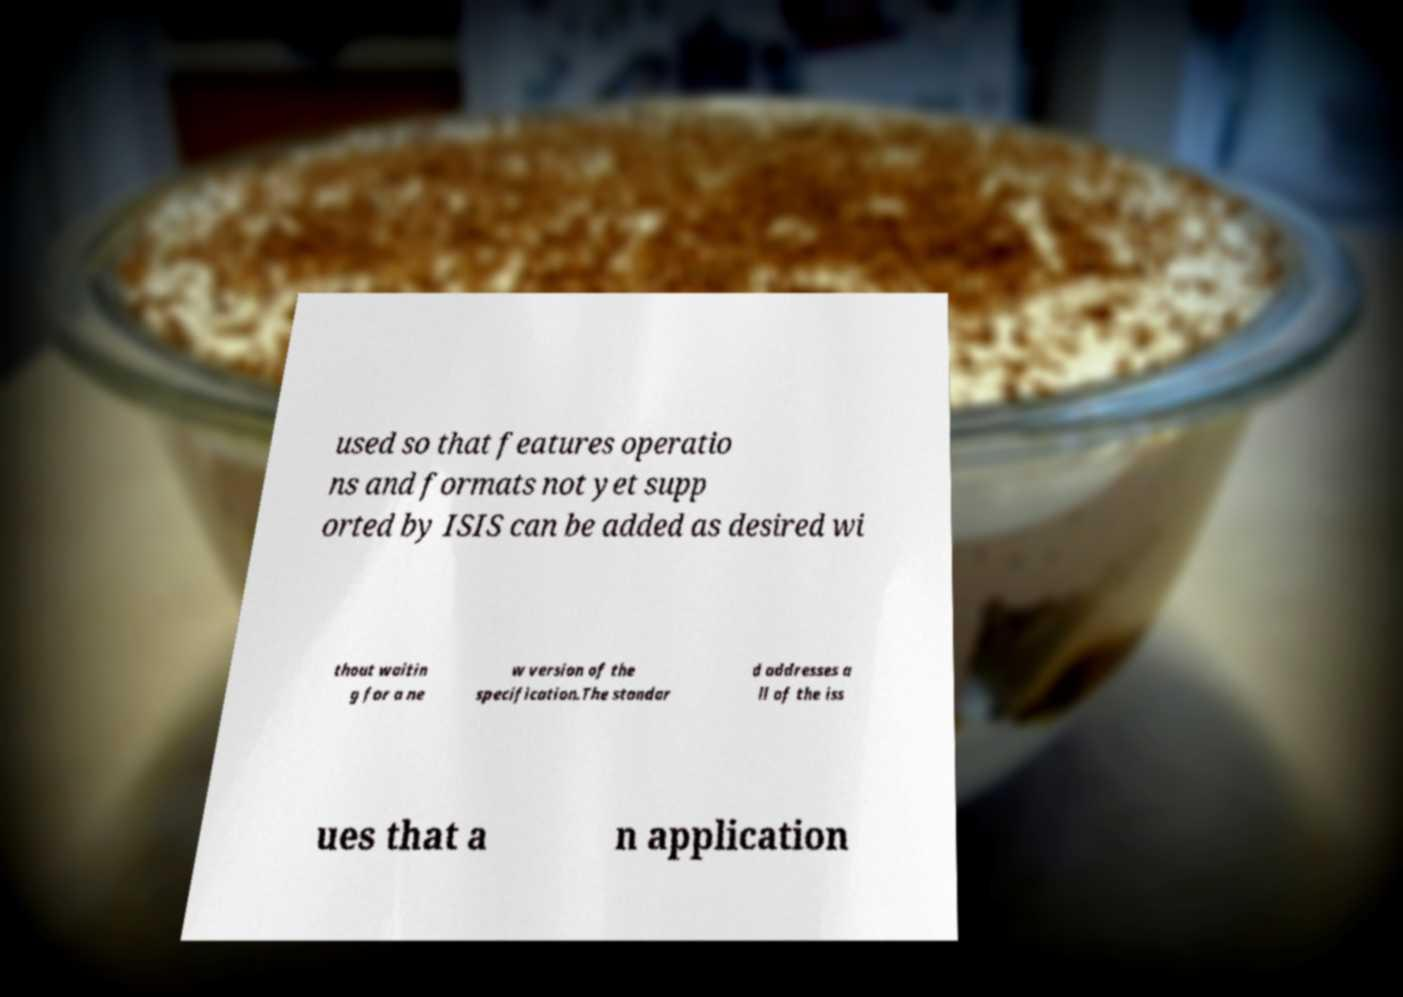Can you read and provide the text displayed in the image?This photo seems to have some interesting text. Can you extract and type it out for me? used so that features operatio ns and formats not yet supp orted by ISIS can be added as desired wi thout waitin g for a ne w version of the specification.The standar d addresses a ll of the iss ues that a n application 